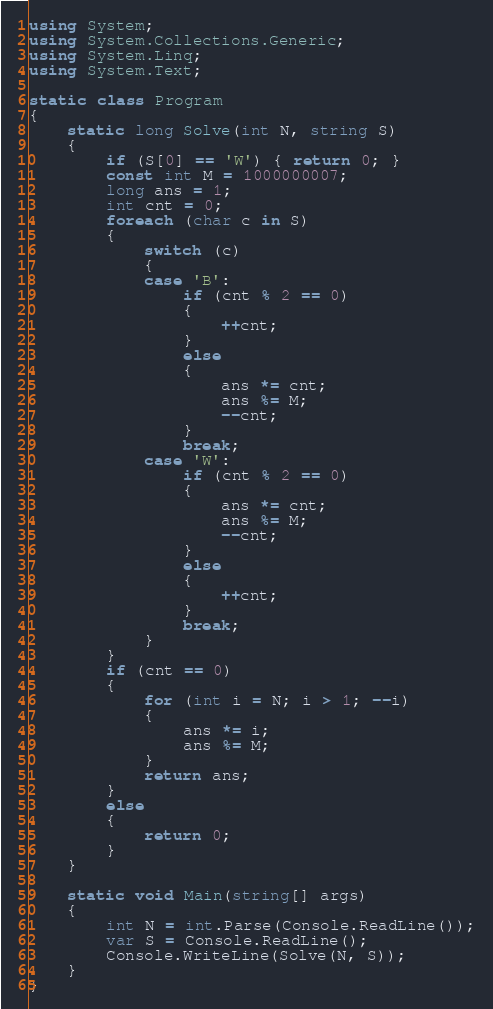Convert code to text. <code><loc_0><loc_0><loc_500><loc_500><_C#_>using System;
using System.Collections.Generic;
using System.Linq;
using System.Text;

static class Program
{
    static long Solve(int N, string S)
    {
        if (S[0] == 'W') { return 0; }
        const int M = 1000000007;
        long ans = 1;
        int cnt = 0;
        foreach (char c in S)
        {
            switch (c)
            {
            case 'B':
                if (cnt % 2 == 0)
                {
                    ++cnt;
                }
                else
                {
                    ans *= cnt;
                    ans %= M;
                    --cnt;
                }
                break;
            case 'W':
                if (cnt % 2 == 0)
                {
                    ans *= cnt;
                    ans %= M;
                    --cnt;
                }
                else
                {
                    ++cnt;
                }
                break;
            }
        }
        if (cnt == 0)
        {
            for (int i = N; i > 1; --i)
            {
                ans *= i;
                ans %= M;
            }
            return ans;
        }
        else
        {
            return 0;
        }
    }

    static void Main(string[] args)
    {
        int N = int.Parse(Console.ReadLine());
        var S = Console.ReadLine();
        Console.WriteLine(Solve(N, S));
    }
}
</code> 